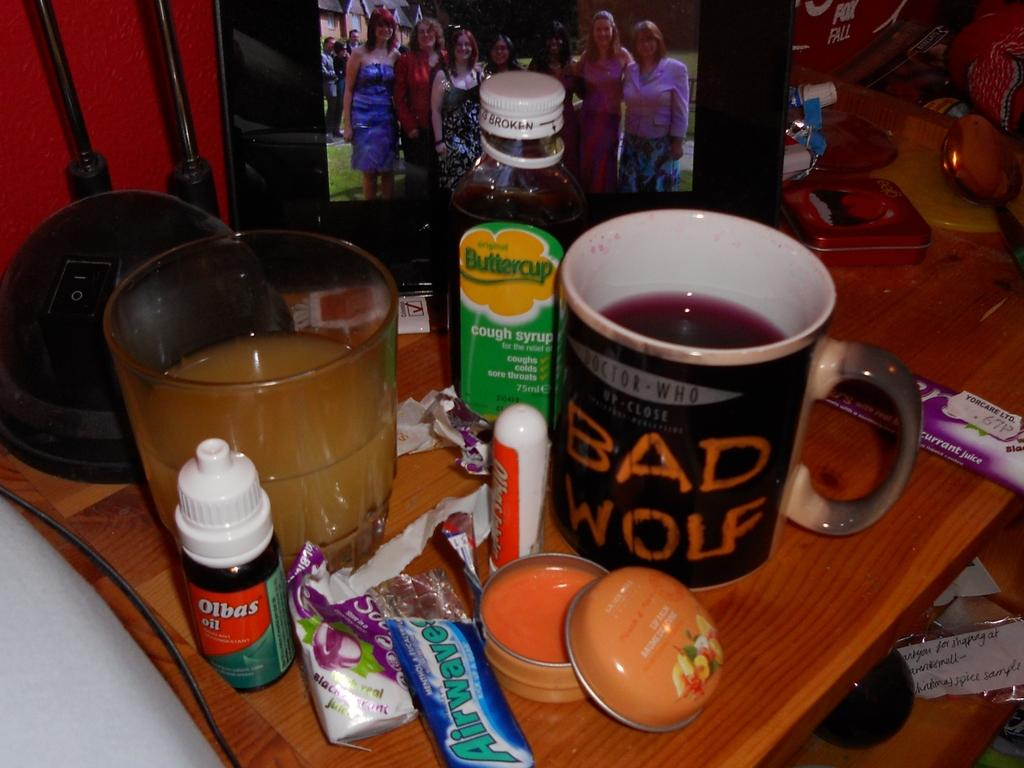<image>
Give a short and clear explanation of the subsequent image. To the left of the Bad Wolf mug is a bottle of Buttercup cough syrup. 